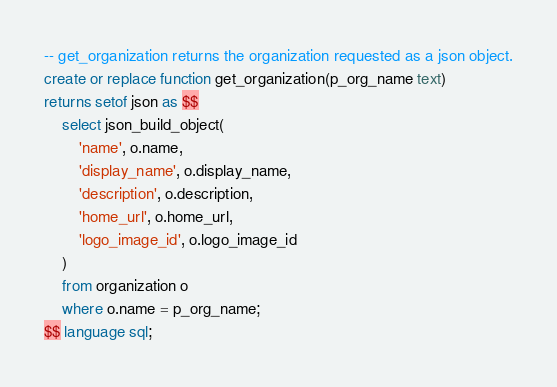<code> <loc_0><loc_0><loc_500><loc_500><_SQL_>-- get_organization returns the organization requested as a json object.
create or replace function get_organization(p_org_name text)
returns setof json as $$
    select json_build_object(
        'name', o.name,
        'display_name', o.display_name,
        'description', o.description,
        'home_url', o.home_url,
        'logo_image_id', o.logo_image_id
    )
    from organization o
    where o.name = p_org_name;
$$ language sql;
</code> 